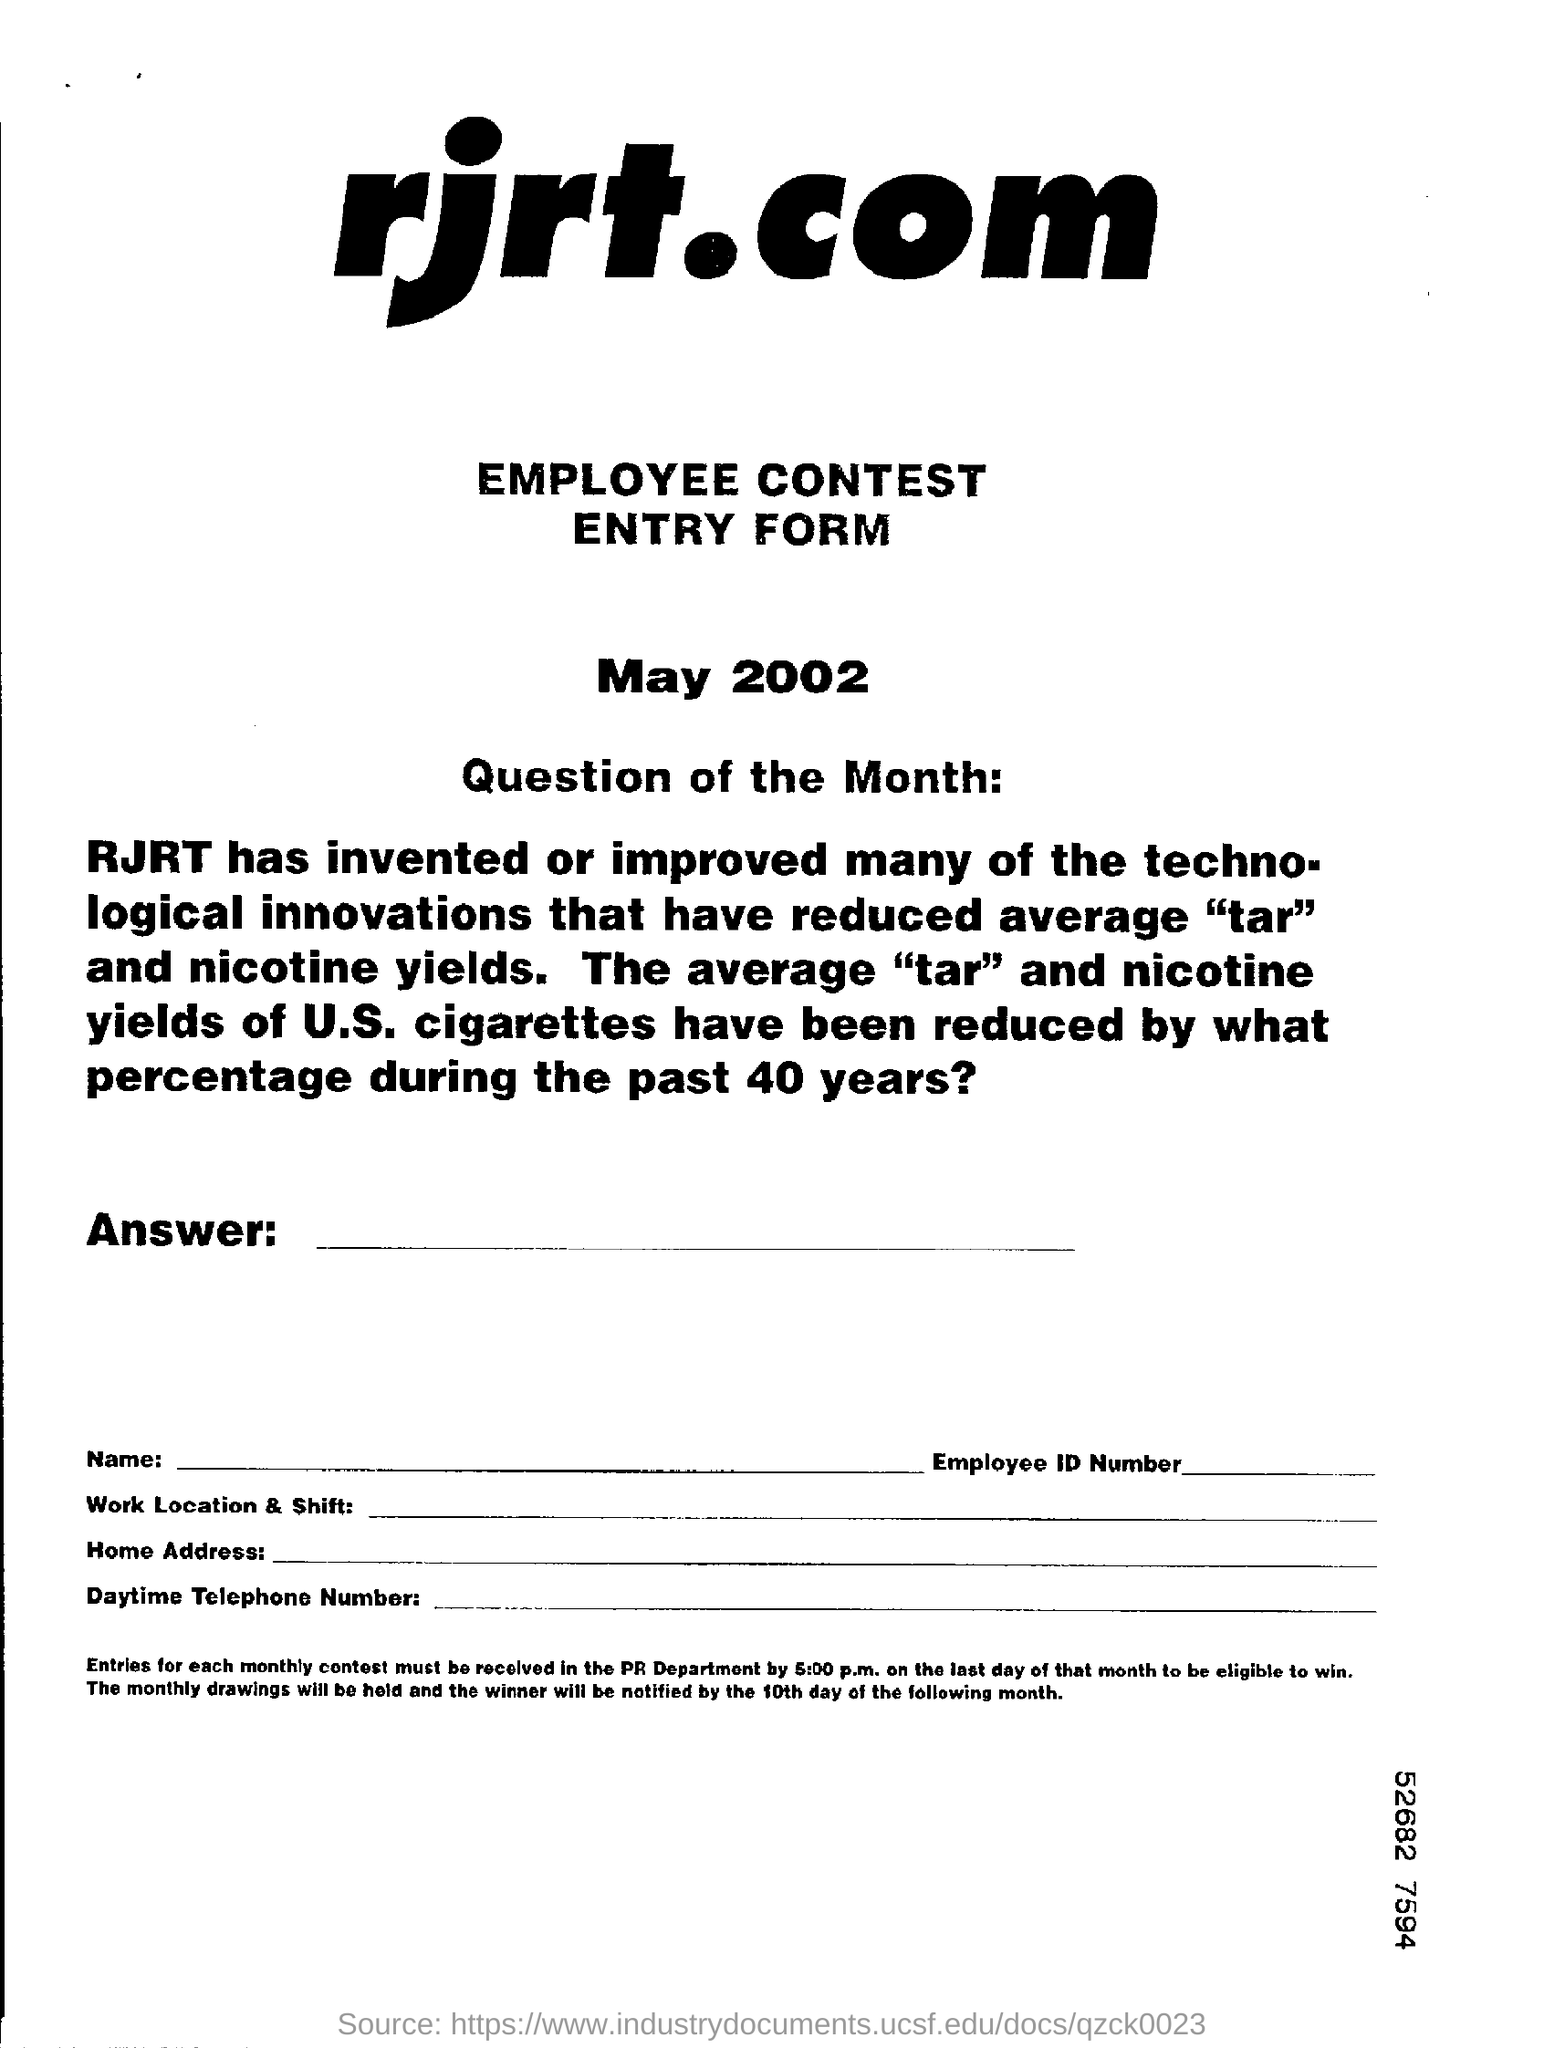Specify some key components in this picture. I am unable to determine the date mentioned in the provided form. It is simply stated as "May 2002...". 